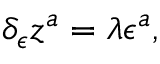Convert formula to latex. <formula><loc_0><loc_0><loc_500><loc_500>\delta _ { \epsilon } z ^ { a } = \lambda \epsilon ^ { a } ,</formula> 